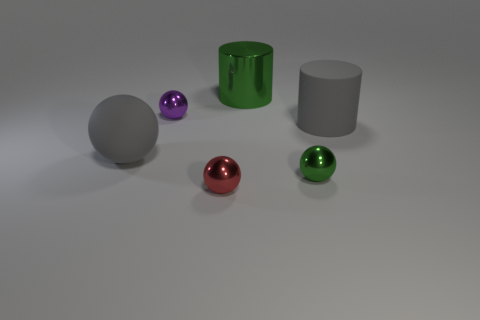Subtract all shiny balls. How many balls are left? 1 Subtract 1 balls. How many balls are left? 3 Subtract all purple spheres. How many spheres are left? 3 Add 2 big gray spheres. How many objects exist? 8 Subtract all yellow balls. Subtract all gray cylinders. How many balls are left? 4 Subtract all spheres. How many objects are left? 2 Subtract all gray rubber cubes. Subtract all red metallic objects. How many objects are left? 5 Add 4 big rubber things. How many big rubber things are left? 6 Add 6 large brown metal balls. How many large brown metal balls exist? 6 Subtract 0 yellow cubes. How many objects are left? 6 